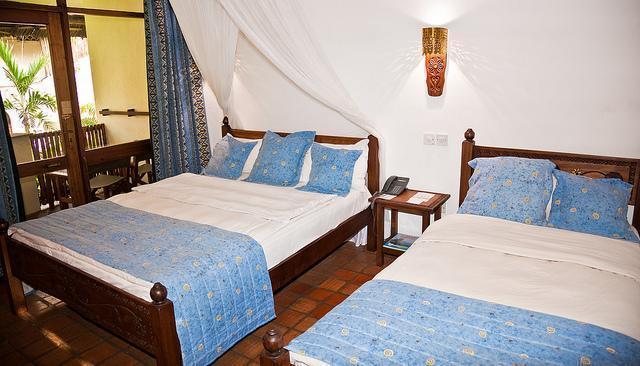What size are these beds?
Make your selection and explain in format: 'Answer: answer
Rationale: rationale.'
Options: Twin, king, full size, queen. Answer: full size.
Rationale: Two regular sized beds can be seen in the room. 